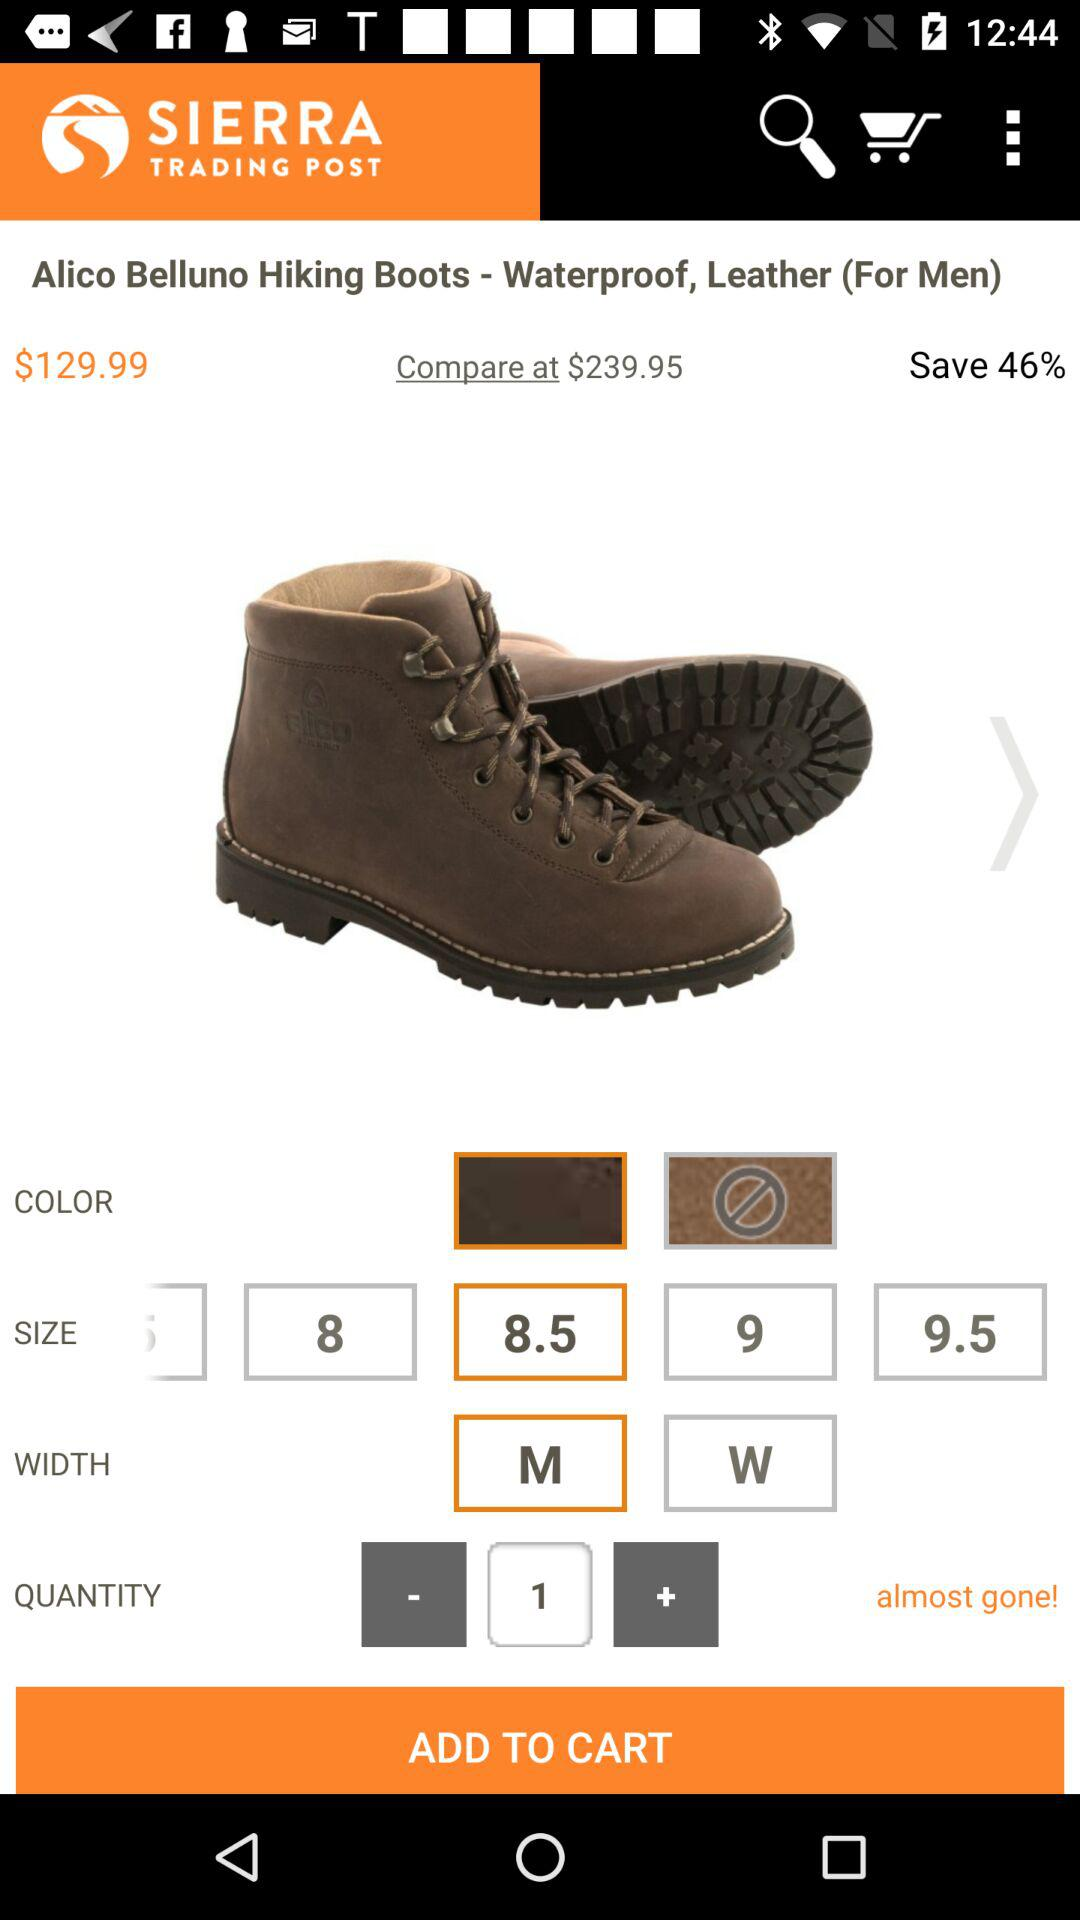What is the name of website?
When the provided information is insufficient, respond with <no answer>. <no answer> 